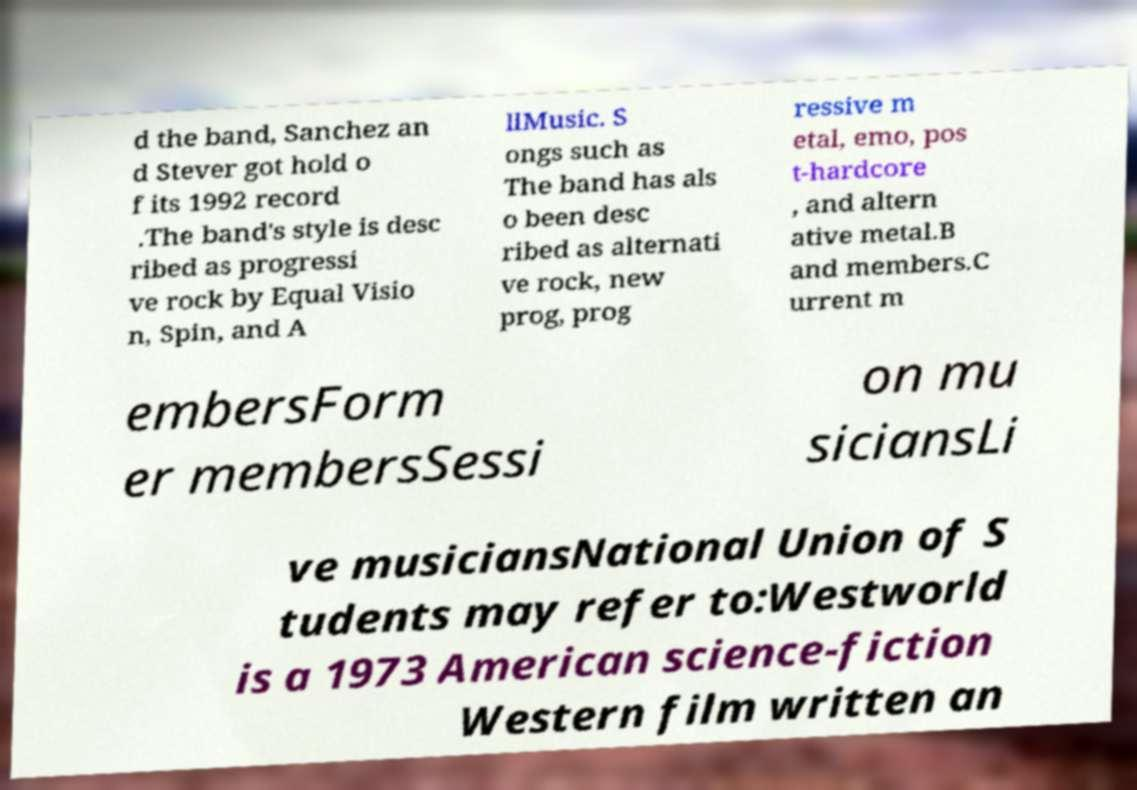Could you assist in decoding the text presented in this image and type it out clearly? d the band, Sanchez an d Stever got hold o f its 1992 record .The band's style is desc ribed as progressi ve rock by Equal Visio n, Spin, and A llMusic. S ongs such as The band has als o been desc ribed as alternati ve rock, new prog, prog ressive m etal, emo, pos t-hardcore , and altern ative metal.B and members.C urrent m embersForm er membersSessi on mu siciansLi ve musiciansNational Union of S tudents may refer to:Westworld is a 1973 American science-fiction Western film written an 